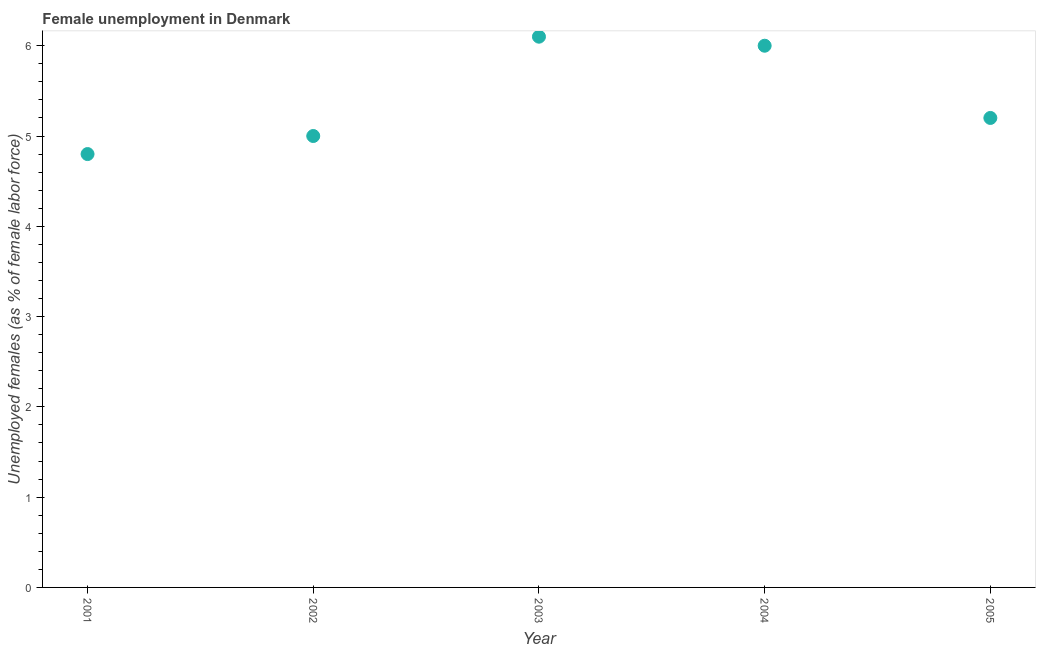Across all years, what is the maximum unemployed females population?
Your answer should be compact. 6.1. Across all years, what is the minimum unemployed females population?
Your answer should be compact. 4.8. In which year was the unemployed females population minimum?
Provide a short and direct response. 2001. What is the sum of the unemployed females population?
Give a very brief answer. 27.1. What is the difference between the unemployed females population in 2002 and 2004?
Offer a terse response. -1. What is the average unemployed females population per year?
Your response must be concise. 5.42. What is the median unemployed females population?
Provide a short and direct response. 5.2. Do a majority of the years between 2002 and 2003 (inclusive) have unemployed females population greater than 3.8 %?
Your answer should be very brief. Yes. What is the ratio of the unemployed females population in 2001 to that in 2003?
Keep it short and to the point. 0.79. Is the unemployed females population in 2001 less than that in 2003?
Keep it short and to the point. Yes. What is the difference between the highest and the second highest unemployed females population?
Your answer should be compact. 0.1. What is the difference between the highest and the lowest unemployed females population?
Give a very brief answer. 1.3. In how many years, is the unemployed females population greater than the average unemployed females population taken over all years?
Keep it short and to the point. 2. How many dotlines are there?
Provide a succinct answer. 1. How many years are there in the graph?
Your answer should be very brief. 5. What is the title of the graph?
Keep it short and to the point. Female unemployment in Denmark. What is the label or title of the X-axis?
Your answer should be compact. Year. What is the label or title of the Y-axis?
Provide a short and direct response. Unemployed females (as % of female labor force). What is the Unemployed females (as % of female labor force) in 2001?
Give a very brief answer. 4.8. What is the Unemployed females (as % of female labor force) in 2002?
Keep it short and to the point. 5. What is the Unemployed females (as % of female labor force) in 2003?
Your answer should be compact. 6.1. What is the Unemployed females (as % of female labor force) in 2005?
Ensure brevity in your answer.  5.2. What is the difference between the Unemployed females (as % of female labor force) in 2001 and 2002?
Ensure brevity in your answer.  -0.2. What is the difference between the Unemployed females (as % of female labor force) in 2001 and 2003?
Your answer should be compact. -1.3. What is the difference between the Unemployed females (as % of female labor force) in 2001 and 2004?
Provide a succinct answer. -1.2. What is the difference between the Unemployed females (as % of female labor force) in 2002 and 2004?
Provide a short and direct response. -1. What is the difference between the Unemployed females (as % of female labor force) in 2002 and 2005?
Your answer should be compact. -0.2. What is the ratio of the Unemployed females (as % of female labor force) in 2001 to that in 2003?
Give a very brief answer. 0.79. What is the ratio of the Unemployed females (as % of female labor force) in 2001 to that in 2004?
Your answer should be compact. 0.8. What is the ratio of the Unemployed females (as % of female labor force) in 2001 to that in 2005?
Offer a terse response. 0.92. What is the ratio of the Unemployed females (as % of female labor force) in 2002 to that in 2003?
Provide a succinct answer. 0.82. What is the ratio of the Unemployed females (as % of female labor force) in 2002 to that in 2004?
Offer a terse response. 0.83. What is the ratio of the Unemployed females (as % of female labor force) in 2003 to that in 2004?
Provide a short and direct response. 1.02. What is the ratio of the Unemployed females (as % of female labor force) in 2003 to that in 2005?
Provide a succinct answer. 1.17. What is the ratio of the Unemployed females (as % of female labor force) in 2004 to that in 2005?
Your response must be concise. 1.15. 